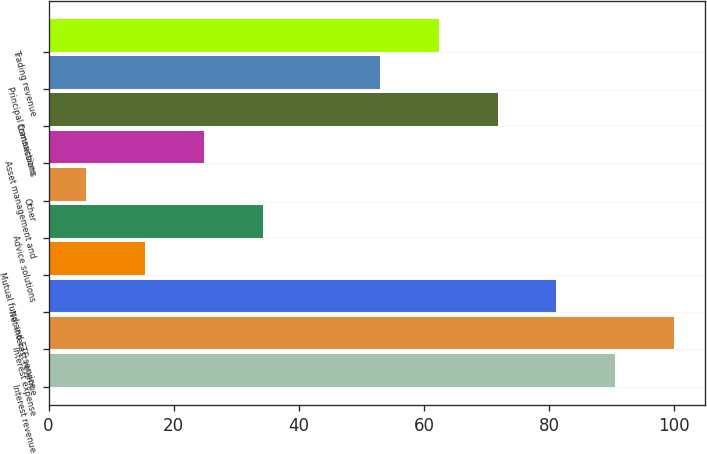Convert chart to OTSL. <chart><loc_0><loc_0><loc_500><loc_500><bar_chart><fcel>Interest revenue<fcel>Interest expense<fcel>Net interest revenue<fcel>Mutual fund and ETF service<fcel>Advice solutions<fcel>Other<fcel>Asset management and<fcel>Commissions<fcel>Principal transactions<fcel>Trading revenue<nl><fcel>90.6<fcel>100<fcel>81.2<fcel>15.4<fcel>34.2<fcel>6<fcel>24.8<fcel>71.8<fcel>53<fcel>62.4<nl></chart> 